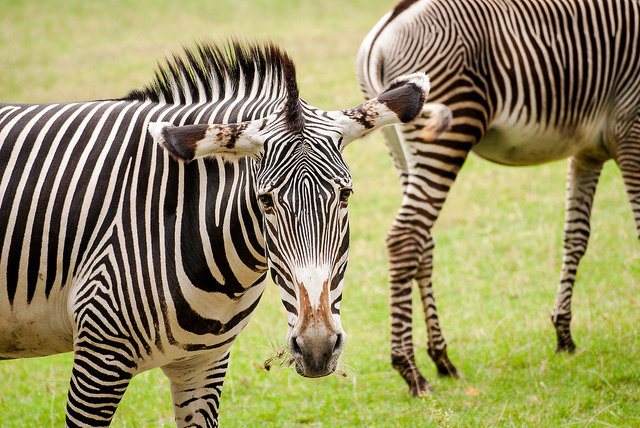Is there anything particularly unique about the physical features of these zebras? Each zebra has a unique pattern of stripes, much like human fingerprints. In this image, you can observe the subtle differences in stripe width and spacing between the two individuals. Additionally, the well-defined stripes near their eyes and the intricate patterns down their necks exemplify the complex beauty of their markings. This distinct striping can serve multiple purposes, from camouflage and insect deterrence to social bonding within the herd. 